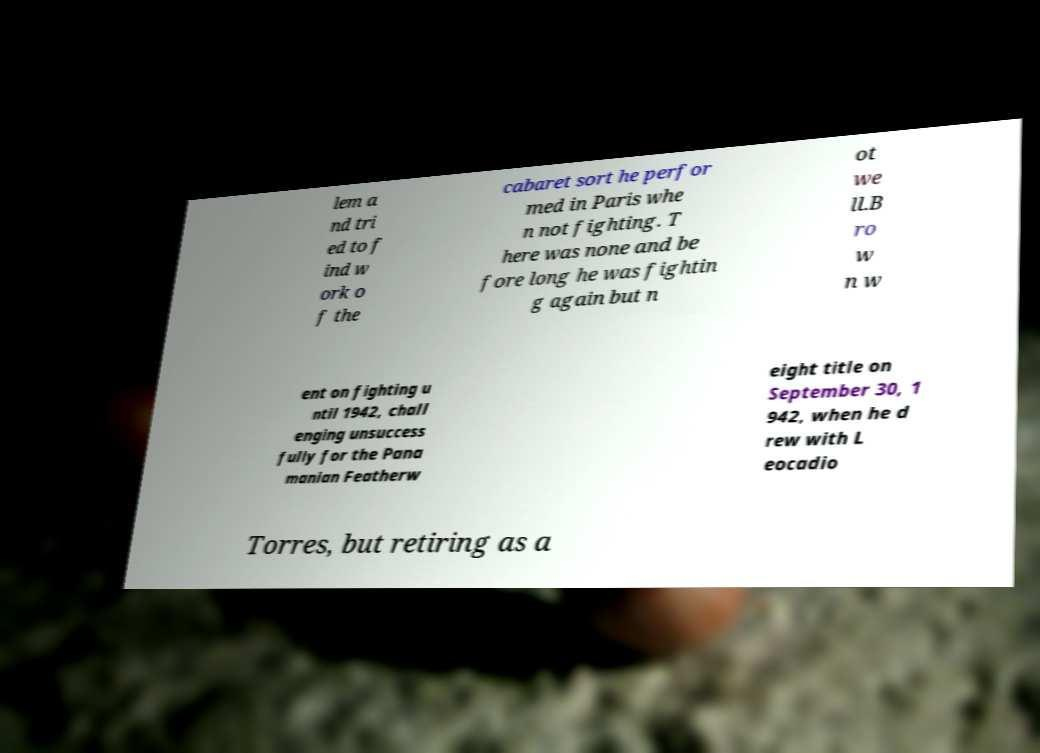There's text embedded in this image that I need extracted. Can you transcribe it verbatim? lem a nd tri ed to f ind w ork o f the cabaret sort he perfor med in Paris whe n not fighting. T here was none and be fore long he was fightin g again but n ot we ll.B ro w n w ent on fighting u ntil 1942, chall enging unsuccess fully for the Pana manian Featherw eight title on September 30, 1 942, when he d rew with L eocadio Torres, but retiring as a 